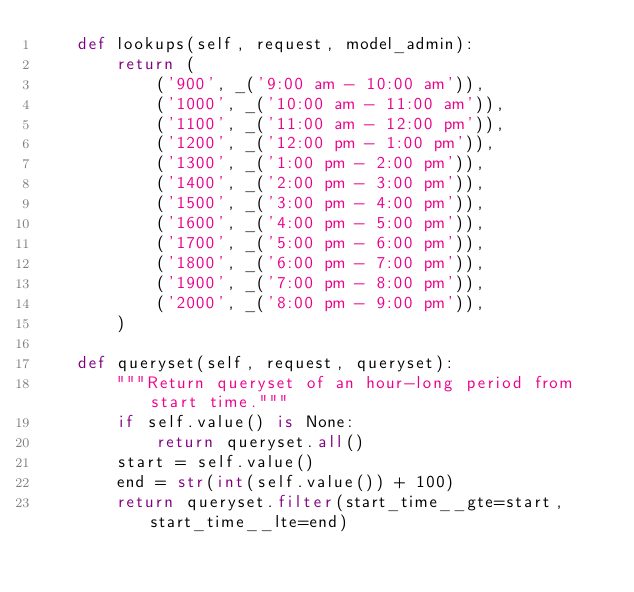<code> <loc_0><loc_0><loc_500><loc_500><_Python_>    def lookups(self, request, model_admin):
        return (
            ('900', _('9:00 am - 10:00 am')),
            ('1000', _('10:00 am - 11:00 am')),
            ('1100', _('11:00 am - 12:00 pm')),
            ('1200', _('12:00 pm - 1:00 pm')),
            ('1300', _('1:00 pm - 2:00 pm')),
            ('1400', _('2:00 pm - 3:00 pm')),
            ('1500', _('3:00 pm - 4:00 pm')),
            ('1600', _('4:00 pm - 5:00 pm')),
            ('1700', _('5:00 pm - 6:00 pm')),
            ('1800', _('6:00 pm - 7:00 pm')),
            ('1900', _('7:00 pm - 8:00 pm')),
            ('2000', _('8:00 pm - 9:00 pm')),
        )

    def queryset(self, request, queryset):
        """Return queryset of an hour-long period from start time."""
        if self.value() is None:
            return queryset.all()
        start = self.value()
        end = str(int(self.value()) + 100)
        return queryset.filter(start_time__gte=start, start_time__lte=end)
</code> 